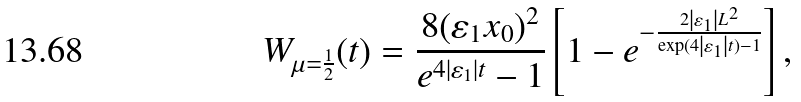<formula> <loc_0><loc_0><loc_500><loc_500>W _ { \mu = \frac { 1 } { 2 } } ( t ) = \frac { 8 ( \varepsilon _ { 1 } x _ { 0 } ) ^ { 2 } } { e ^ { 4 \left | \varepsilon _ { 1 } \right | t } - 1 } \left [ 1 - e ^ { - \frac { 2 \left | \varepsilon _ { 1 } \right | L ^ { 2 } } { \exp ( 4 \left | \varepsilon _ { 1 } \right | t ) - 1 } } \right ] ,</formula> 